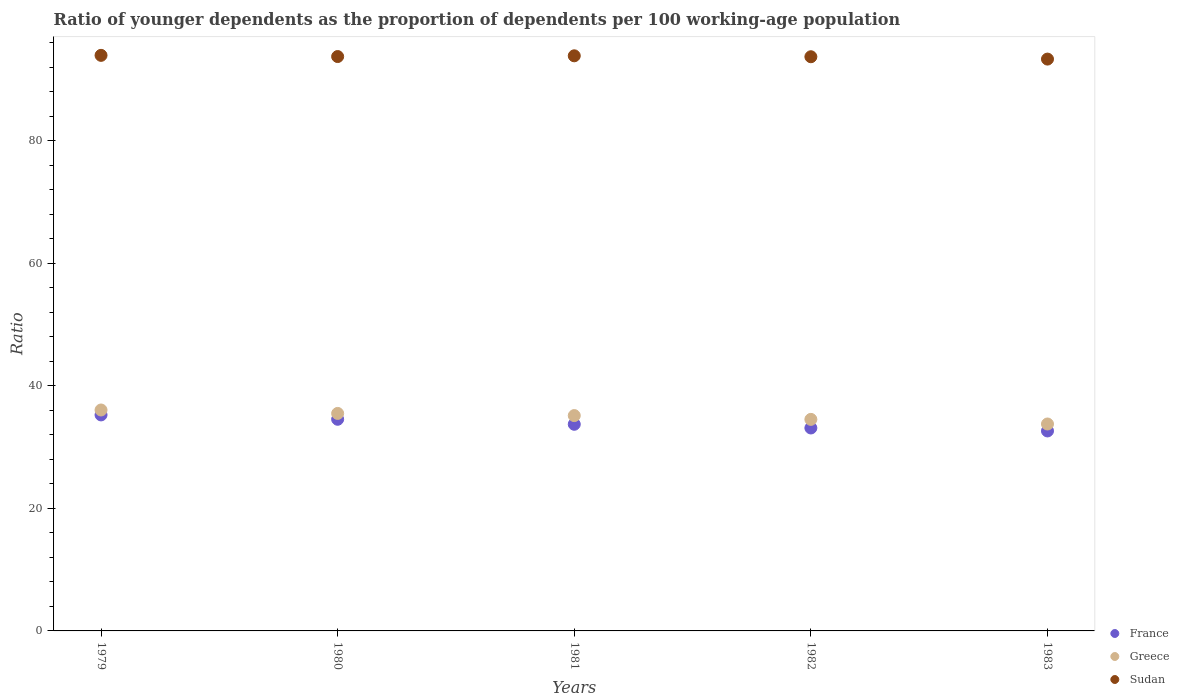How many different coloured dotlines are there?
Provide a succinct answer. 3. What is the age dependency ratio(young) in Sudan in 1980?
Offer a very short reply. 93.75. Across all years, what is the maximum age dependency ratio(young) in Greece?
Your answer should be very brief. 36.06. Across all years, what is the minimum age dependency ratio(young) in Greece?
Give a very brief answer. 33.78. In which year was the age dependency ratio(young) in Sudan maximum?
Ensure brevity in your answer.  1979. What is the total age dependency ratio(young) in Greece in the graph?
Give a very brief answer. 175.01. What is the difference between the age dependency ratio(young) in France in 1980 and that in 1981?
Make the answer very short. 0.81. What is the difference between the age dependency ratio(young) in Greece in 1979 and the age dependency ratio(young) in France in 1982?
Offer a terse response. 2.94. What is the average age dependency ratio(young) in Sudan per year?
Ensure brevity in your answer.  93.72. In the year 1980, what is the difference between the age dependency ratio(young) in Sudan and age dependency ratio(young) in France?
Ensure brevity in your answer.  59.21. In how many years, is the age dependency ratio(young) in Sudan greater than 68?
Offer a terse response. 5. What is the ratio of the age dependency ratio(young) in Greece in 1980 to that in 1983?
Provide a short and direct response. 1.05. Is the age dependency ratio(young) in Sudan in 1979 less than that in 1982?
Make the answer very short. No. Is the difference between the age dependency ratio(young) in Sudan in 1982 and 1983 greater than the difference between the age dependency ratio(young) in France in 1982 and 1983?
Provide a succinct answer. No. What is the difference between the highest and the second highest age dependency ratio(young) in Sudan?
Offer a terse response. 0.07. What is the difference between the highest and the lowest age dependency ratio(young) in Greece?
Provide a succinct answer. 2.29. In how many years, is the age dependency ratio(young) in France greater than the average age dependency ratio(young) in France taken over all years?
Your answer should be very brief. 2. Is it the case that in every year, the sum of the age dependency ratio(young) in Sudan and age dependency ratio(young) in France  is greater than the age dependency ratio(young) in Greece?
Your response must be concise. Yes. Does the age dependency ratio(young) in Greece monotonically increase over the years?
Keep it short and to the point. No. Is the age dependency ratio(young) in Greece strictly greater than the age dependency ratio(young) in Sudan over the years?
Your response must be concise. No. Is the age dependency ratio(young) in France strictly less than the age dependency ratio(young) in Greece over the years?
Offer a terse response. Yes. How many dotlines are there?
Make the answer very short. 3. How many years are there in the graph?
Keep it short and to the point. 5. What is the difference between two consecutive major ticks on the Y-axis?
Make the answer very short. 20. Does the graph contain any zero values?
Give a very brief answer. No. How many legend labels are there?
Keep it short and to the point. 3. What is the title of the graph?
Your answer should be very brief. Ratio of younger dependents as the proportion of dependents per 100 working-age population. What is the label or title of the X-axis?
Make the answer very short. Years. What is the label or title of the Y-axis?
Keep it short and to the point. Ratio. What is the Ratio of France in 1979?
Make the answer very short. 35.26. What is the Ratio in Greece in 1979?
Make the answer very short. 36.06. What is the Ratio of Sudan in 1979?
Give a very brief answer. 93.95. What is the Ratio of France in 1980?
Offer a very short reply. 34.54. What is the Ratio of Greece in 1980?
Give a very brief answer. 35.5. What is the Ratio of Sudan in 1980?
Your answer should be very brief. 93.75. What is the Ratio of France in 1981?
Keep it short and to the point. 33.73. What is the Ratio in Greece in 1981?
Make the answer very short. 35.15. What is the Ratio in Sudan in 1981?
Keep it short and to the point. 93.87. What is the Ratio in France in 1982?
Your response must be concise. 33.12. What is the Ratio of Greece in 1982?
Make the answer very short. 34.53. What is the Ratio in Sudan in 1982?
Ensure brevity in your answer.  93.72. What is the Ratio in France in 1983?
Your answer should be compact. 32.64. What is the Ratio of Greece in 1983?
Give a very brief answer. 33.78. What is the Ratio of Sudan in 1983?
Offer a terse response. 93.34. Across all years, what is the maximum Ratio in France?
Offer a very short reply. 35.26. Across all years, what is the maximum Ratio in Greece?
Make the answer very short. 36.06. Across all years, what is the maximum Ratio in Sudan?
Your response must be concise. 93.95. Across all years, what is the minimum Ratio in France?
Your answer should be very brief. 32.64. Across all years, what is the minimum Ratio in Greece?
Your response must be concise. 33.78. Across all years, what is the minimum Ratio in Sudan?
Give a very brief answer. 93.34. What is the total Ratio in France in the graph?
Provide a short and direct response. 169.3. What is the total Ratio in Greece in the graph?
Give a very brief answer. 175.01. What is the total Ratio of Sudan in the graph?
Give a very brief answer. 468.62. What is the difference between the Ratio in France in 1979 and that in 1980?
Give a very brief answer. 0.71. What is the difference between the Ratio in Greece in 1979 and that in 1980?
Your response must be concise. 0.56. What is the difference between the Ratio in Sudan in 1979 and that in 1980?
Your answer should be compact. 0.19. What is the difference between the Ratio of France in 1979 and that in 1981?
Your answer should be compact. 1.53. What is the difference between the Ratio in Greece in 1979 and that in 1981?
Give a very brief answer. 0.91. What is the difference between the Ratio in Sudan in 1979 and that in 1981?
Offer a terse response. 0.07. What is the difference between the Ratio in France in 1979 and that in 1982?
Keep it short and to the point. 2.13. What is the difference between the Ratio of Greece in 1979 and that in 1982?
Offer a terse response. 1.53. What is the difference between the Ratio of Sudan in 1979 and that in 1982?
Offer a terse response. 0.23. What is the difference between the Ratio in France in 1979 and that in 1983?
Make the answer very short. 2.62. What is the difference between the Ratio of Greece in 1979 and that in 1983?
Your answer should be very brief. 2.29. What is the difference between the Ratio in Sudan in 1979 and that in 1983?
Provide a short and direct response. 0.61. What is the difference between the Ratio in France in 1980 and that in 1981?
Your answer should be very brief. 0.81. What is the difference between the Ratio in Greece in 1980 and that in 1981?
Your response must be concise. 0.35. What is the difference between the Ratio in Sudan in 1980 and that in 1981?
Make the answer very short. -0.12. What is the difference between the Ratio in France in 1980 and that in 1982?
Ensure brevity in your answer.  1.42. What is the difference between the Ratio of Greece in 1980 and that in 1982?
Your response must be concise. 0.97. What is the difference between the Ratio in Sudan in 1980 and that in 1982?
Ensure brevity in your answer.  0.03. What is the difference between the Ratio of France in 1980 and that in 1983?
Provide a short and direct response. 1.91. What is the difference between the Ratio of Greece in 1980 and that in 1983?
Provide a succinct answer. 1.73. What is the difference between the Ratio of Sudan in 1980 and that in 1983?
Provide a succinct answer. 0.42. What is the difference between the Ratio of France in 1981 and that in 1982?
Offer a terse response. 0.61. What is the difference between the Ratio in Greece in 1981 and that in 1982?
Your response must be concise. 0.62. What is the difference between the Ratio of Sudan in 1981 and that in 1982?
Give a very brief answer. 0.15. What is the difference between the Ratio of France in 1981 and that in 1983?
Your answer should be compact. 1.09. What is the difference between the Ratio in Greece in 1981 and that in 1983?
Provide a succinct answer. 1.37. What is the difference between the Ratio of Sudan in 1981 and that in 1983?
Your response must be concise. 0.54. What is the difference between the Ratio in France in 1982 and that in 1983?
Provide a short and direct response. 0.48. What is the difference between the Ratio of Greece in 1982 and that in 1983?
Keep it short and to the point. 0.75. What is the difference between the Ratio of Sudan in 1982 and that in 1983?
Your response must be concise. 0.38. What is the difference between the Ratio of France in 1979 and the Ratio of Greece in 1980?
Provide a succinct answer. -0.24. What is the difference between the Ratio of France in 1979 and the Ratio of Sudan in 1980?
Give a very brief answer. -58.49. What is the difference between the Ratio in Greece in 1979 and the Ratio in Sudan in 1980?
Provide a short and direct response. -57.69. What is the difference between the Ratio in France in 1979 and the Ratio in Greece in 1981?
Keep it short and to the point. 0.11. What is the difference between the Ratio of France in 1979 and the Ratio of Sudan in 1981?
Give a very brief answer. -58.61. What is the difference between the Ratio in Greece in 1979 and the Ratio in Sudan in 1981?
Keep it short and to the point. -57.81. What is the difference between the Ratio in France in 1979 and the Ratio in Greece in 1982?
Offer a terse response. 0.73. What is the difference between the Ratio in France in 1979 and the Ratio in Sudan in 1982?
Offer a very short reply. -58.46. What is the difference between the Ratio of Greece in 1979 and the Ratio of Sudan in 1982?
Ensure brevity in your answer.  -57.66. What is the difference between the Ratio of France in 1979 and the Ratio of Greece in 1983?
Your answer should be very brief. 1.48. What is the difference between the Ratio in France in 1979 and the Ratio in Sudan in 1983?
Your answer should be very brief. -58.08. What is the difference between the Ratio of Greece in 1979 and the Ratio of Sudan in 1983?
Offer a very short reply. -57.27. What is the difference between the Ratio of France in 1980 and the Ratio of Greece in 1981?
Give a very brief answer. -0.6. What is the difference between the Ratio in France in 1980 and the Ratio in Sudan in 1981?
Your answer should be very brief. -59.33. What is the difference between the Ratio in Greece in 1980 and the Ratio in Sudan in 1981?
Your answer should be very brief. -58.37. What is the difference between the Ratio in France in 1980 and the Ratio in Greece in 1982?
Give a very brief answer. 0.02. What is the difference between the Ratio in France in 1980 and the Ratio in Sudan in 1982?
Give a very brief answer. -59.17. What is the difference between the Ratio in Greece in 1980 and the Ratio in Sudan in 1982?
Offer a very short reply. -58.22. What is the difference between the Ratio of France in 1980 and the Ratio of Greece in 1983?
Make the answer very short. 0.77. What is the difference between the Ratio in France in 1980 and the Ratio in Sudan in 1983?
Give a very brief answer. -58.79. What is the difference between the Ratio of Greece in 1980 and the Ratio of Sudan in 1983?
Your answer should be very brief. -57.84. What is the difference between the Ratio in France in 1981 and the Ratio in Greece in 1982?
Make the answer very short. -0.8. What is the difference between the Ratio of France in 1981 and the Ratio of Sudan in 1982?
Make the answer very short. -59.99. What is the difference between the Ratio of Greece in 1981 and the Ratio of Sudan in 1982?
Provide a succinct answer. -58.57. What is the difference between the Ratio in France in 1981 and the Ratio in Greece in 1983?
Give a very brief answer. -0.05. What is the difference between the Ratio in France in 1981 and the Ratio in Sudan in 1983?
Keep it short and to the point. -59.61. What is the difference between the Ratio in Greece in 1981 and the Ratio in Sudan in 1983?
Your answer should be compact. -58.19. What is the difference between the Ratio in France in 1982 and the Ratio in Greece in 1983?
Your answer should be compact. -0.65. What is the difference between the Ratio in France in 1982 and the Ratio in Sudan in 1983?
Give a very brief answer. -60.21. What is the difference between the Ratio of Greece in 1982 and the Ratio of Sudan in 1983?
Your answer should be compact. -58.81. What is the average Ratio in France per year?
Provide a short and direct response. 33.86. What is the average Ratio of Greece per year?
Ensure brevity in your answer.  35. What is the average Ratio in Sudan per year?
Keep it short and to the point. 93.72. In the year 1979, what is the difference between the Ratio of France and Ratio of Greece?
Offer a terse response. -0.8. In the year 1979, what is the difference between the Ratio of France and Ratio of Sudan?
Your answer should be compact. -58.69. In the year 1979, what is the difference between the Ratio of Greece and Ratio of Sudan?
Your response must be concise. -57.88. In the year 1980, what is the difference between the Ratio in France and Ratio in Greece?
Keep it short and to the point. -0.96. In the year 1980, what is the difference between the Ratio in France and Ratio in Sudan?
Ensure brevity in your answer.  -59.21. In the year 1980, what is the difference between the Ratio in Greece and Ratio in Sudan?
Offer a terse response. -58.25. In the year 1981, what is the difference between the Ratio in France and Ratio in Greece?
Make the answer very short. -1.42. In the year 1981, what is the difference between the Ratio in France and Ratio in Sudan?
Keep it short and to the point. -60.14. In the year 1981, what is the difference between the Ratio in Greece and Ratio in Sudan?
Provide a short and direct response. -58.72. In the year 1982, what is the difference between the Ratio in France and Ratio in Greece?
Your response must be concise. -1.4. In the year 1982, what is the difference between the Ratio in France and Ratio in Sudan?
Give a very brief answer. -60.59. In the year 1982, what is the difference between the Ratio of Greece and Ratio of Sudan?
Your response must be concise. -59.19. In the year 1983, what is the difference between the Ratio of France and Ratio of Greece?
Your answer should be very brief. -1.14. In the year 1983, what is the difference between the Ratio in France and Ratio in Sudan?
Your answer should be very brief. -60.7. In the year 1983, what is the difference between the Ratio of Greece and Ratio of Sudan?
Make the answer very short. -59.56. What is the ratio of the Ratio in France in 1979 to that in 1980?
Provide a short and direct response. 1.02. What is the ratio of the Ratio of Greece in 1979 to that in 1980?
Keep it short and to the point. 1.02. What is the ratio of the Ratio of Sudan in 1979 to that in 1980?
Your answer should be very brief. 1. What is the ratio of the Ratio in France in 1979 to that in 1981?
Offer a very short reply. 1.05. What is the ratio of the Ratio of France in 1979 to that in 1982?
Provide a short and direct response. 1.06. What is the ratio of the Ratio in Greece in 1979 to that in 1982?
Your answer should be compact. 1.04. What is the ratio of the Ratio in France in 1979 to that in 1983?
Offer a terse response. 1.08. What is the ratio of the Ratio in Greece in 1979 to that in 1983?
Give a very brief answer. 1.07. What is the ratio of the Ratio of Sudan in 1979 to that in 1983?
Your response must be concise. 1.01. What is the ratio of the Ratio in France in 1980 to that in 1981?
Provide a short and direct response. 1.02. What is the ratio of the Ratio of France in 1980 to that in 1982?
Your answer should be very brief. 1.04. What is the ratio of the Ratio in Greece in 1980 to that in 1982?
Your answer should be compact. 1.03. What is the ratio of the Ratio in France in 1980 to that in 1983?
Provide a short and direct response. 1.06. What is the ratio of the Ratio in Greece in 1980 to that in 1983?
Your answer should be compact. 1.05. What is the ratio of the Ratio of Sudan in 1980 to that in 1983?
Your response must be concise. 1. What is the ratio of the Ratio of France in 1981 to that in 1982?
Provide a short and direct response. 1.02. What is the ratio of the Ratio of Greece in 1981 to that in 1982?
Your response must be concise. 1.02. What is the ratio of the Ratio of Sudan in 1981 to that in 1982?
Your response must be concise. 1. What is the ratio of the Ratio of France in 1981 to that in 1983?
Your answer should be very brief. 1.03. What is the ratio of the Ratio in Greece in 1981 to that in 1983?
Provide a succinct answer. 1.04. What is the ratio of the Ratio in France in 1982 to that in 1983?
Provide a short and direct response. 1.01. What is the ratio of the Ratio in Greece in 1982 to that in 1983?
Your answer should be compact. 1.02. What is the ratio of the Ratio in Sudan in 1982 to that in 1983?
Give a very brief answer. 1. What is the difference between the highest and the second highest Ratio in France?
Make the answer very short. 0.71. What is the difference between the highest and the second highest Ratio of Greece?
Your answer should be compact. 0.56. What is the difference between the highest and the second highest Ratio of Sudan?
Your answer should be very brief. 0.07. What is the difference between the highest and the lowest Ratio of France?
Provide a succinct answer. 2.62. What is the difference between the highest and the lowest Ratio in Greece?
Ensure brevity in your answer.  2.29. What is the difference between the highest and the lowest Ratio in Sudan?
Provide a short and direct response. 0.61. 